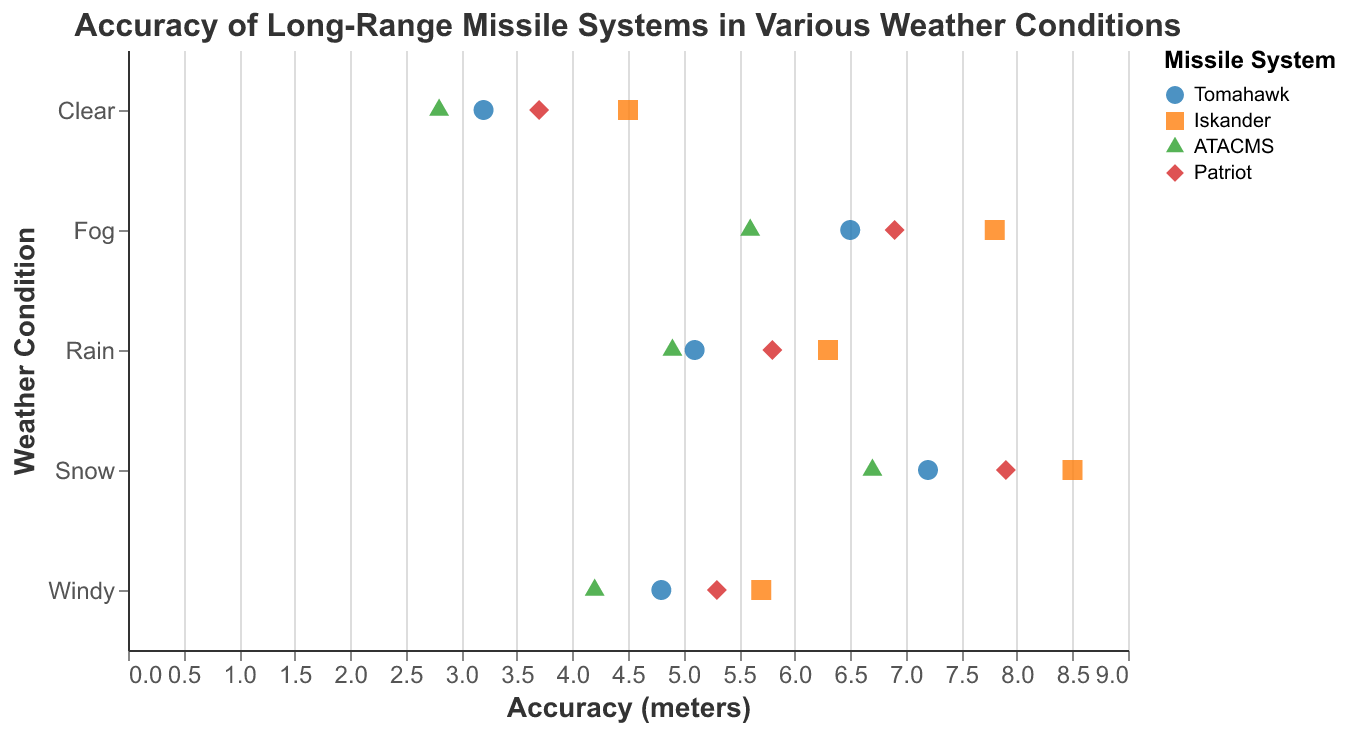How many weather conditions are represented in the plot? Look at the y-axis labels to count the distinct weather conditions shown.
Answer: 5 What is the color used to represent the "ATACMS" missile system? Refer to the legend in the plot where missile systems are mapped to specific colors.
Answer: Green Which weather condition shows the highest accuracy for the "Tomahawk" missile system? Locate the points corresponding to the "Tomahawk" missile system (identified by the same shape) and compare the Accuracy (meters) across weather conditions. The lowest accuracy value indicates the highest accuracy.
Answer: Clear What is the average accuracy of the "Iskander" missile system in all weather conditions? Extract the accuracy values for "Iskander" in clear, rain, snow, fog, and windy conditions (4.5, 6.3, 8.5, 7.8, 5.7). Sum these values and divide by 5 to find the average.
Answer: 6.56 Which missile system shows the largest variation in accuracy across different weather conditions? For each missile system, calculate the range (max - min) of the accuracy values across weather conditions. Compare these ranges to find the largest variation.
Answer: Iskander Is there a weather condition where the accuracy values of all missile systems are relatively close to each other? Examine the points within each weather condition and observe the spread (or range) of accuracy values. Look for a condition where the points are tightly clustered.
Answer: Clear What is the difference in accuracy between "ATACMS" and "Patriot" in foggy conditions? Find the accuracy values for "ATACMS" and "Patriot" in foggy conditions (5.6 and 6.9, respectively). Subtract the lower value from the higher value.
Answer: 1.3 Which missile system performs best in snowy conditions? Identify the points corresponding to snowy conditions and compare the accuracy values for all Missile Systems. The lowest accuracy value indicates the best performance.
Answer: ATACMS What is the median accuracy value for all missile systems in rainy conditions? List the accuracy values in rainy conditions for all missile systems (5.1, 6.3, 4.9, 5.8). Sort these values and find the median.
Answer: 5.45 How does the accuracy of the "Patriot" missile system vary between clear and windy conditions? Compare the accuracy values for "Patriot" in clear and windy conditions (3.7 and 5.3, respectively) and note whether the accuracy improves or worsens.
Answer: Worsens 